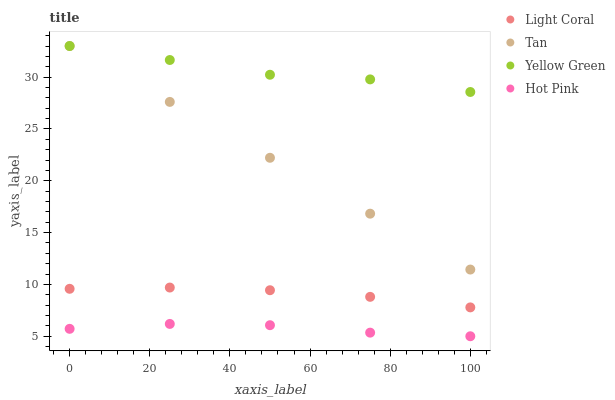Does Hot Pink have the minimum area under the curve?
Answer yes or no. Yes. Does Yellow Green have the maximum area under the curve?
Answer yes or no. Yes. Does Tan have the minimum area under the curve?
Answer yes or no. No. Does Tan have the maximum area under the curve?
Answer yes or no. No. Is Tan the smoothest?
Answer yes or no. Yes. Is Yellow Green the roughest?
Answer yes or no. Yes. Is Hot Pink the smoothest?
Answer yes or no. No. Is Hot Pink the roughest?
Answer yes or no. No. Does Hot Pink have the lowest value?
Answer yes or no. Yes. Does Tan have the lowest value?
Answer yes or no. No. Does Yellow Green have the highest value?
Answer yes or no. Yes. Does Hot Pink have the highest value?
Answer yes or no. No. Is Hot Pink less than Tan?
Answer yes or no. Yes. Is Yellow Green greater than Light Coral?
Answer yes or no. Yes. Does Tan intersect Yellow Green?
Answer yes or no. Yes. Is Tan less than Yellow Green?
Answer yes or no. No. Is Tan greater than Yellow Green?
Answer yes or no. No. Does Hot Pink intersect Tan?
Answer yes or no. No. 